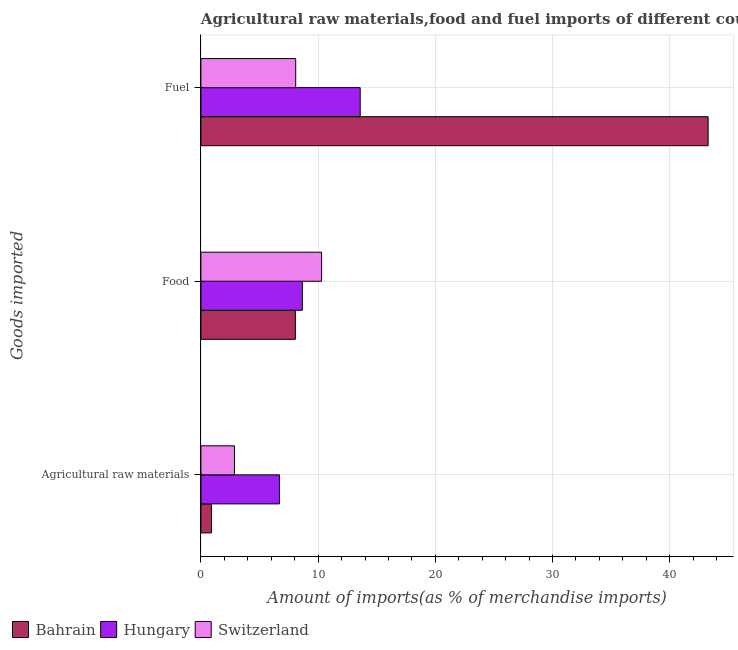How many different coloured bars are there?
Give a very brief answer. 3. How many groups of bars are there?
Offer a very short reply. 3. Are the number of bars per tick equal to the number of legend labels?
Offer a very short reply. Yes. What is the label of the 1st group of bars from the top?
Keep it short and to the point. Fuel. What is the percentage of fuel imports in Hungary?
Ensure brevity in your answer.  13.59. Across all countries, what is the maximum percentage of raw materials imports?
Offer a very short reply. 6.7. Across all countries, what is the minimum percentage of fuel imports?
Your answer should be very brief. 8.09. In which country was the percentage of food imports maximum?
Make the answer very short. Switzerland. In which country was the percentage of raw materials imports minimum?
Give a very brief answer. Bahrain. What is the total percentage of food imports in the graph?
Offer a terse response. 27.01. What is the difference between the percentage of fuel imports in Bahrain and that in Switzerland?
Offer a very short reply. 35.19. What is the difference between the percentage of food imports in Hungary and the percentage of fuel imports in Switzerland?
Offer a terse response. 0.57. What is the average percentage of raw materials imports per country?
Make the answer very short. 3.49. What is the difference between the percentage of fuel imports and percentage of raw materials imports in Bahrain?
Your answer should be very brief. 42.38. What is the ratio of the percentage of raw materials imports in Bahrain to that in Switzerland?
Provide a short and direct response. 0.31. Is the difference between the percentage of raw materials imports in Switzerland and Bahrain greater than the difference between the percentage of food imports in Switzerland and Bahrain?
Provide a succinct answer. No. What is the difference between the highest and the second highest percentage of raw materials imports?
Give a very brief answer. 3.84. What is the difference between the highest and the lowest percentage of raw materials imports?
Provide a short and direct response. 5.8. In how many countries, is the percentage of fuel imports greater than the average percentage of fuel imports taken over all countries?
Offer a terse response. 1. What does the 1st bar from the top in Food represents?
Offer a very short reply. Switzerland. What does the 2nd bar from the bottom in Food represents?
Give a very brief answer. Hungary. Is it the case that in every country, the sum of the percentage of raw materials imports and percentage of food imports is greater than the percentage of fuel imports?
Make the answer very short. No. What is the difference between two consecutive major ticks on the X-axis?
Your answer should be compact. 10. Are the values on the major ticks of X-axis written in scientific E-notation?
Offer a terse response. No. Where does the legend appear in the graph?
Offer a terse response. Bottom left. How many legend labels are there?
Offer a terse response. 3. How are the legend labels stacked?
Offer a very short reply. Horizontal. What is the title of the graph?
Your response must be concise. Agricultural raw materials,food and fuel imports of different countries in 1978. Does "East Asia (developing only)" appear as one of the legend labels in the graph?
Offer a terse response. No. What is the label or title of the X-axis?
Your answer should be very brief. Amount of imports(as % of merchandise imports). What is the label or title of the Y-axis?
Ensure brevity in your answer.  Goods imported. What is the Amount of imports(as % of merchandise imports) of Bahrain in Agricultural raw materials?
Your answer should be very brief. 0.9. What is the Amount of imports(as % of merchandise imports) of Hungary in Agricultural raw materials?
Keep it short and to the point. 6.7. What is the Amount of imports(as % of merchandise imports) of Switzerland in Agricultural raw materials?
Make the answer very short. 2.86. What is the Amount of imports(as % of merchandise imports) of Bahrain in Food?
Ensure brevity in your answer.  8.06. What is the Amount of imports(as % of merchandise imports) in Hungary in Food?
Make the answer very short. 8.65. What is the Amount of imports(as % of merchandise imports) in Switzerland in Food?
Keep it short and to the point. 10.3. What is the Amount of imports(as % of merchandise imports) in Bahrain in Fuel?
Offer a very short reply. 43.28. What is the Amount of imports(as % of merchandise imports) in Hungary in Fuel?
Your answer should be very brief. 13.59. What is the Amount of imports(as % of merchandise imports) of Switzerland in Fuel?
Keep it short and to the point. 8.09. Across all Goods imported, what is the maximum Amount of imports(as % of merchandise imports) of Bahrain?
Offer a very short reply. 43.28. Across all Goods imported, what is the maximum Amount of imports(as % of merchandise imports) in Hungary?
Make the answer very short. 13.59. Across all Goods imported, what is the maximum Amount of imports(as % of merchandise imports) in Switzerland?
Keep it short and to the point. 10.3. Across all Goods imported, what is the minimum Amount of imports(as % of merchandise imports) in Bahrain?
Make the answer very short. 0.9. Across all Goods imported, what is the minimum Amount of imports(as % of merchandise imports) in Hungary?
Offer a very short reply. 6.7. Across all Goods imported, what is the minimum Amount of imports(as % of merchandise imports) of Switzerland?
Make the answer very short. 2.86. What is the total Amount of imports(as % of merchandise imports) in Bahrain in the graph?
Provide a succinct answer. 52.24. What is the total Amount of imports(as % of merchandise imports) of Hungary in the graph?
Your answer should be compact. 28.95. What is the total Amount of imports(as % of merchandise imports) of Switzerland in the graph?
Ensure brevity in your answer.  21.25. What is the difference between the Amount of imports(as % of merchandise imports) of Bahrain in Agricultural raw materials and that in Food?
Provide a short and direct response. -7.16. What is the difference between the Amount of imports(as % of merchandise imports) of Hungary in Agricultural raw materials and that in Food?
Your response must be concise. -1.95. What is the difference between the Amount of imports(as % of merchandise imports) of Switzerland in Agricultural raw materials and that in Food?
Offer a terse response. -7.43. What is the difference between the Amount of imports(as % of merchandise imports) in Bahrain in Agricultural raw materials and that in Fuel?
Ensure brevity in your answer.  -42.38. What is the difference between the Amount of imports(as % of merchandise imports) of Hungary in Agricultural raw materials and that in Fuel?
Ensure brevity in your answer.  -6.89. What is the difference between the Amount of imports(as % of merchandise imports) of Switzerland in Agricultural raw materials and that in Fuel?
Keep it short and to the point. -5.23. What is the difference between the Amount of imports(as % of merchandise imports) in Bahrain in Food and that in Fuel?
Your answer should be compact. -35.22. What is the difference between the Amount of imports(as % of merchandise imports) in Hungary in Food and that in Fuel?
Your answer should be very brief. -4.94. What is the difference between the Amount of imports(as % of merchandise imports) in Switzerland in Food and that in Fuel?
Offer a terse response. 2.21. What is the difference between the Amount of imports(as % of merchandise imports) in Bahrain in Agricultural raw materials and the Amount of imports(as % of merchandise imports) in Hungary in Food?
Your answer should be very brief. -7.75. What is the difference between the Amount of imports(as % of merchandise imports) of Bahrain in Agricultural raw materials and the Amount of imports(as % of merchandise imports) of Switzerland in Food?
Keep it short and to the point. -9.4. What is the difference between the Amount of imports(as % of merchandise imports) of Hungary in Agricultural raw materials and the Amount of imports(as % of merchandise imports) of Switzerland in Food?
Offer a very short reply. -3.59. What is the difference between the Amount of imports(as % of merchandise imports) of Bahrain in Agricultural raw materials and the Amount of imports(as % of merchandise imports) of Hungary in Fuel?
Your response must be concise. -12.69. What is the difference between the Amount of imports(as % of merchandise imports) in Bahrain in Agricultural raw materials and the Amount of imports(as % of merchandise imports) in Switzerland in Fuel?
Give a very brief answer. -7.19. What is the difference between the Amount of imports(as % of merchandise imports) in Hungary in Agricultural raw materials and the Amount of imports(as % of merchandise imports) in Switzerland in Fuel?
Offer a terse response. -1.39. What is the difference between the Amount of imports(as % of merchandise imports) of Bahrain in Food and the Amount of imports(as % of merchandise imports) of Hungary in Fuel?
Provide a short and direct response. -5.53. What is the difference between the Amount of imports(as % of merchandise imports) in Bahrain in Food and the Amount of imports(as % of merchandise imports) in Switzerland in Fuel?
Your response must be concise. -0.03. What is the difference between the Amount of imports(as % of merchandise imports) in Hungary in Food and the Amount of imports(as % of merchandise imports) in Switzerland in Fuel?
Your answer should be very brief. 0.57. What is the average Amount of imports(as % of merchandise imports) of Bahrain per Goods imported?
Your answer should be compact. 17.41. What is the average Amount of imports(as % of merchandise imports) of Hungary per Goods imported?
Offer a terse response. 9.65. What is the average Amount of imports(as % of merchandise imports) of Switzerland per Goods imported?
Provide a short and direct response. 7.08. What is the difference between the Amount of imports(as % of merchandise imports) of Bahrain and Amount of imports(as % of merchandise imports) of Hungary in Agricultural raw materials?
Offer a terse response. -5.8. What is the difference between the Amount of imports(as % of merchandise imports) of Bahrain and Amount of imports(as % of merchandise imports) of Switzerland in Agricultural raw materials?
Your response must be concise. -1.96. What is the difference between the Amount of imports(as % of merchandise imports) of Hungary and Amount of imports(as % of merchandise imports) of Switzerland in Agricultural raw materials?
Provide a short and direct response. 3.84. What is the difference between the Amount of imports(as % of merchandise imports) of Bahrain and Amount of imports(as % of merchandise imports) of Hungary in Food?
Your response must be concise. -0.59. What is the difference between the Amount of imports(as % of merchandise imports) of Bahrain and Amount of imports(as % of merchandise imports) of Switzerland in Food?
Ensure brevity in your answer.  -2.24. What is the difference between the Amount of imports(as % of merchandise imports) of Hungary and Amount of imports(as % of merchandise imports) of Switzerland in Food?
Ensure brevity in your answer.  -1.64. What is the difference between the Amount of imports(as % of merchandise imports) in Bahrain and Amount of imports(as % of merchandise imports) in Hungary in Fuel?
Your answer should be very brief. 29.69. What is the difference between the Amount of imports(as % of merchandise imports) in Bahrain and Amount of imports(as % of merchandise imports) in Switzerland in Fuel?
Make the answer very short. 35.19. What is the difference between the Amount of imports(as % of merchandise imports) in Hungary and Amount of imports(as % of merchandise imports) in Switzerland in Fuel?
Make the answer very short. 5.5. What is the ratio of the Amount of imports(as % of merchandise imports) in Bahrain in Agricultural raw materials to that in Food?
Give a very brief answer. 0.11. What is the ratio of the Amount of imports(as % of merchandise imports) in Hungary in Agricultural raw materials to that in Food?
Ensure brevity in your answer.  0.77. What is the ratio of the Amount of imports(as % of merchandise imports) of Switzerland in Agricultural raw materials to that in Food?
Your response must be concise. 0.28. What is the ratio of the Amount of imports(as % of merchandise imports) in Bahrain in Agricultural raw materials to that in Fuel?
Provide a short and direct response. 0.02. What is the ratio of the Amount of imports(as % of merchandise imports) of Hungary in Agricultural raw materials to that in Fuel?
Your answer should be compact. 0.49. What is the ratio of the Amount of imports(as % of merchandise imports) in Switzerland in Agricultural raw materials to that in Fuel?
Ensure brevity in your answer.  0.35. What is the ratio of the Amount of imports(as % of merchandise imports) of Bahrain in Food to that in Fuel?
Give a very brief answer. 0.19. What is the ratio of the Amount of imports(as % of merchandise imports) in Hungary in Food to that in Fuel?
Offer a very short reply. 0.64. What is the ratio of the Amount of imports(as % of merchandise imports) in Switzerland in Food to that in Fuel?
Offer a terse response. 1.27. What is the difference between the highest and the second highest Amount of imports(as % of merchandise imports) of Bahrain?
Provide a short and direct response. 35.22. What is the difference between the highest and the second highest Amount of imports(as % of merchandise imports) of Hungary?
Your answer should be compact. 4.94. What is the difference between the highest and the second highest Amount of imports(as % of merchandise imports) of Switzerland?
Your response must be concise. 2.21. What is the difference between the highest and the lowest Amount of imports(as % of merchandise imports) in Bahrain?
Provide a succinct answer. 42.38. What is the difference between the highest and the lowest Amount of imports(as % of merchandise imports) of Hungary?
Make the answer very short. 6.89. What is the difference between the highest and the lowest Amount of imports(as % of merchandise imports) of Switzerland?
Ensure brevity in your answer.  7.43. 